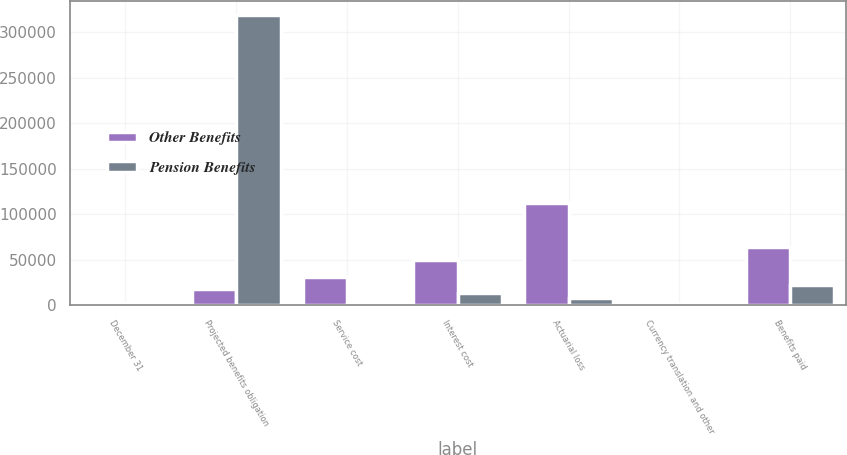Convert chart. <chart><loc_0><loc_0><loc_500><loc_500><stacked_bar_chart><ecel><fcel>December 31<fcel>Projected benefits obligation<fcel>Service cost<fcel>Interest cost<fcel>Actuarial loss<fcel>Currency translation and other<fcel>Benefits paid<nl><fcel>Other Benefits<fcel>2012<fcel>18047.5<fcel>30823<fcel>49909<fcel>112700<fcel>1903<fcel>64439<nl><fcel>Pension Benefits<fcel>2012<fcel>318415<fcel>1172<fcel>13258<fcel>7916<fcel>370<fcel>22837<nl></chart> 